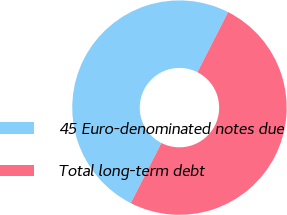<chart> <loc_0><loc_0><loc_500><loc_500><pie_chart><fcel>45 Euro-denominated notes due<fcel>Total long-term debt<nl><fcel>49.99%<fcel>50.01%<nl></chart> 